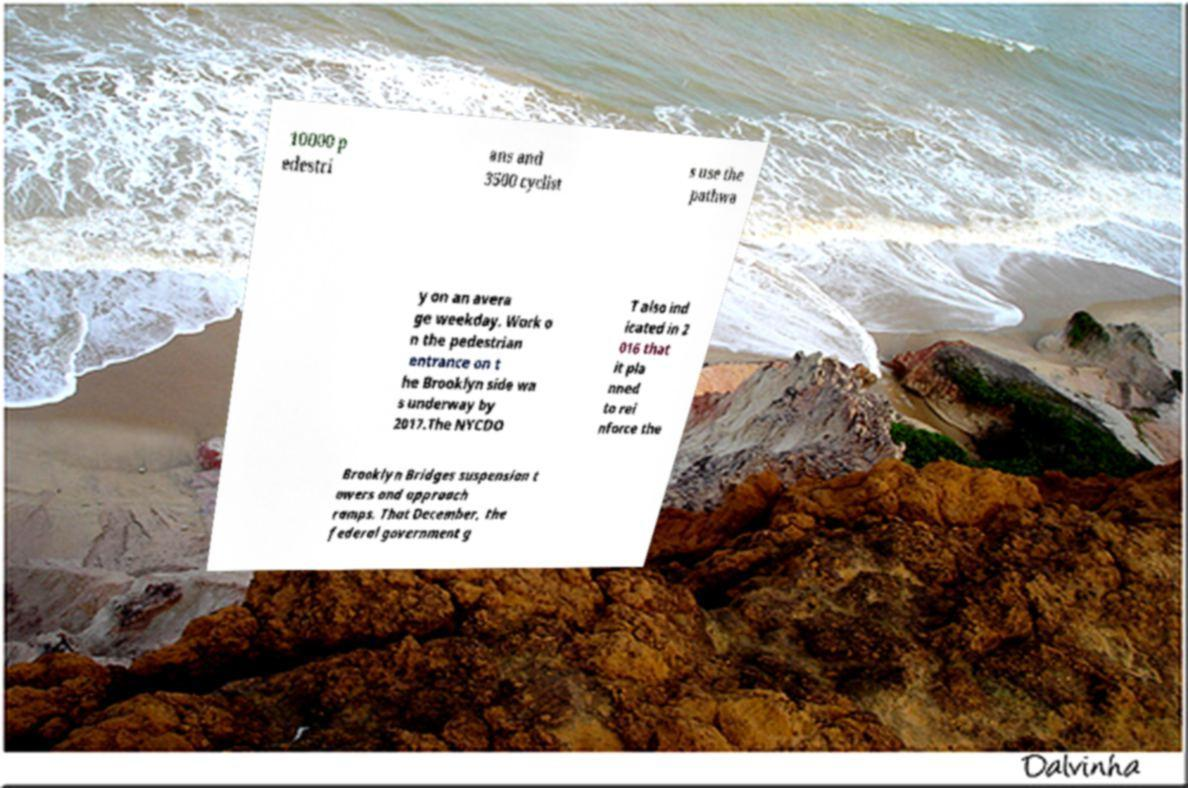Can you read and provide the text displayed in the image?This photo seems to have some interesting text. Can you extract and type it out for me? 10000 p edestri ans and 3500 cyclist s use the pathwa y on an avera ge weekday. Work o n the pedestrian entrance on t he Brooklyn side wa s underway by 2017.The NYCDO T also ind icated in 2 016 that it pla nned to rei nforce the Brooklyn Bridges suspension t owers and approach ramps. That December, the federal government g 